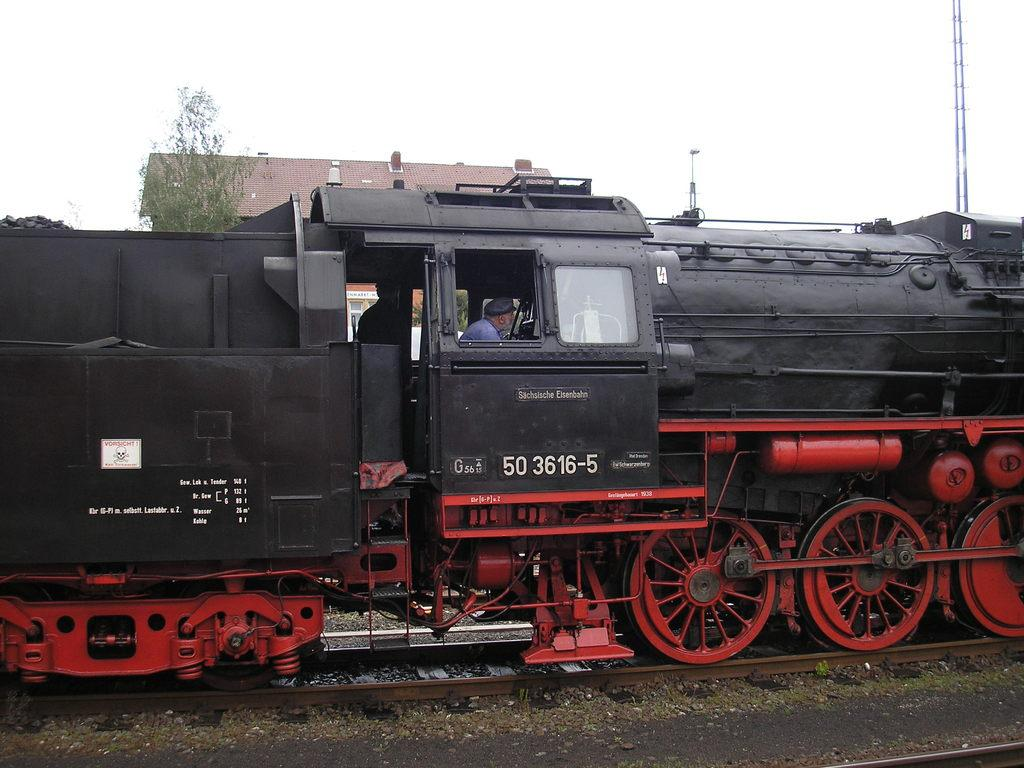Who is present in the image? There is a person in the image. Where is the person located? The person is on a train. What is the train doing? The train is on a railway track. What can be seen in the background of the image? There is a tower, a pole, a house, and a tree in the background of the image. What type of cherry is being used to glue the oven in the image? There is no cherry, glue, or oven present in the image. 